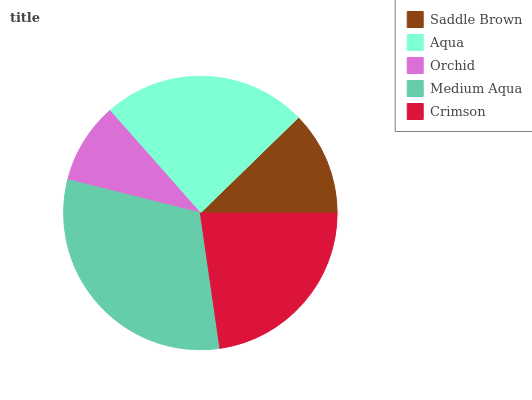Is Orchid the minimum?
Answer yes or no. Yes. Is Medium Aqua the maximum?
Answer yes or no. Yes. Is Aqua the minimum?
Answer yes or no. No. Is Aqua the maximum?
Answer yes or no. No. Is Aqua greater than Saddle Brown?
Answer yes or no. Yes. Is Saddle Brown less than Aqua?
Answer yes or no. Yes. Is Saddle Brown greater than Aqua?
Answer yes or no. No. Is Aqua less than Saddle Brown?
Answer yes or no. No. Is Crimson the high median?
Answer yes or no. Yes. Is Crimson the low median?
Answer yes or no. Yes. Is Saddle Brown the high median?
Answer yes or no. No. Is Aqua the low median?
Answer yes or no. No. 